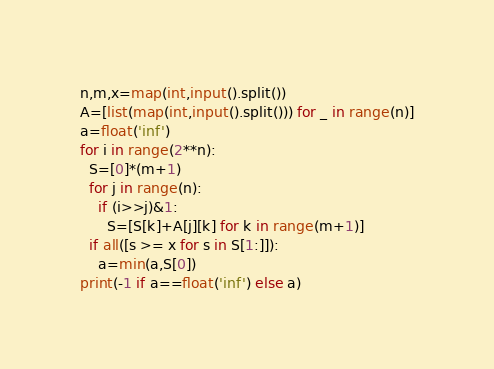<code> <loc_0><loc_0><loc_500><loc_500><_Python_>n,m,x=map(int,input().split())
A=[list(map(int,input().split())) for _ in range(n)]
a=float('inf')
for i in range(2**n):
  S=[0]*(m+1)
  for j in range(n):
    if (i>>j)&1:
      S=[S[k]+A[j][k] for k in range(m+1)]
  if all([s >= x for s in S[1:]]):
    a=min(a,S[0])
print(-1 if a==float('inf') else a)</code> 